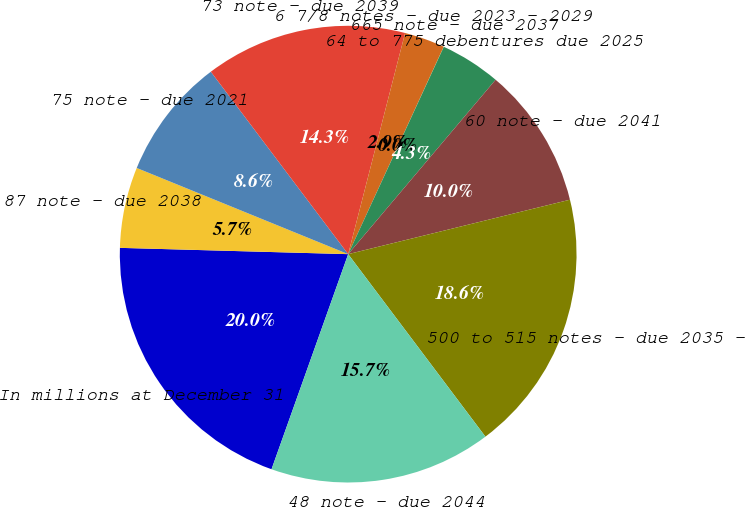Convert chart. <chart><loc_0><loc_0><loc_500><loc_500><pie_chart><fcel>In millions at December 31<fcel>87 note - due 2038<fcel>75 note - due 2021<fcel>73 note - due 2039<fcel>6 7/8 notes - due 2023 - 2029<fcel>665 note - due 2037<fcel>64 to 775 debentures due 2025<fcel>60 note - due 2041<fcel>500 to 515 notes - due 2035 -<fcel>48 note - due 2044<nl><fcel>19.99%<fcel>5.72%<fcel>8.57%<fcel>14.28%<fcel>2.86%<fcel>0.01%<fcel>4.29%<fcel>10.0%<fcel>18.57%<fcel>15.71%<nl></chart> 